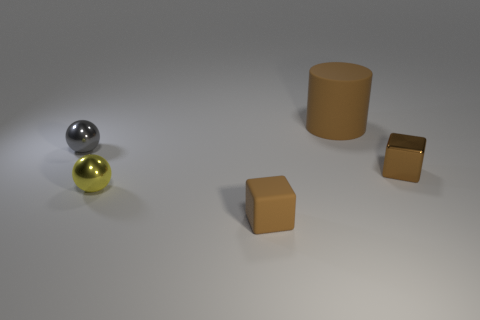What materials seem to be used for the objects in the image? The objects appear to be made of different materials. The spheres look metallic, with reflective surfaces suggesting possibly steel or aluminum. The cylinder and boxes seem to be matte, possibly made of plastic or a similar non-metallic material. 